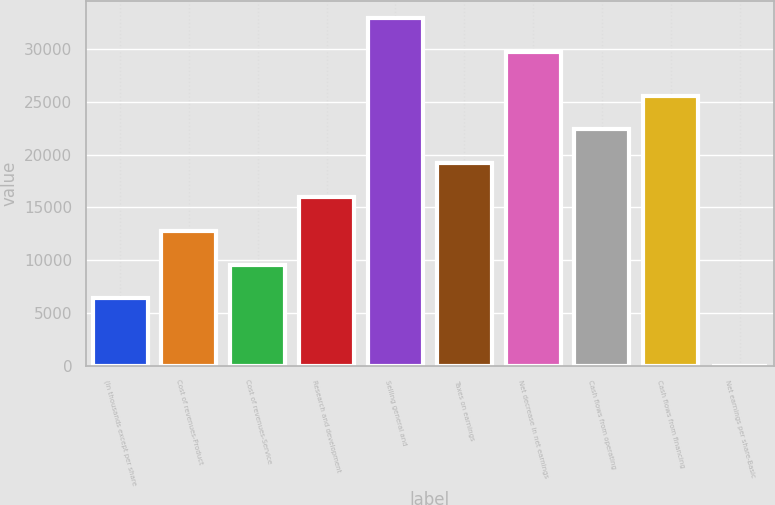Convert chart to OTSL. <chart><loc_0><loc_0><loc_500><loc_500><bar_chart><fcel>(In thousands except per share<fcel>Cost of revenues-Product<fcel>Cost of revenues-Service<fcel>Research and development<fcel>Selling general and<fcel>Taxes on earnings<fcel>Net decrease in net earnings<fcel>Cash flows from operating<fcel>Cash flows from financing<fcel>Net earnings per share-Basic<nl><fcel>6393.59<fcel>12787<fcel>9590.27<fcel>15983.6<fcel>32906.7<fcel>19180.3<fcel>29710<fcel>22377<fcel>25573.7<fcel>0.23<nl></chart> 